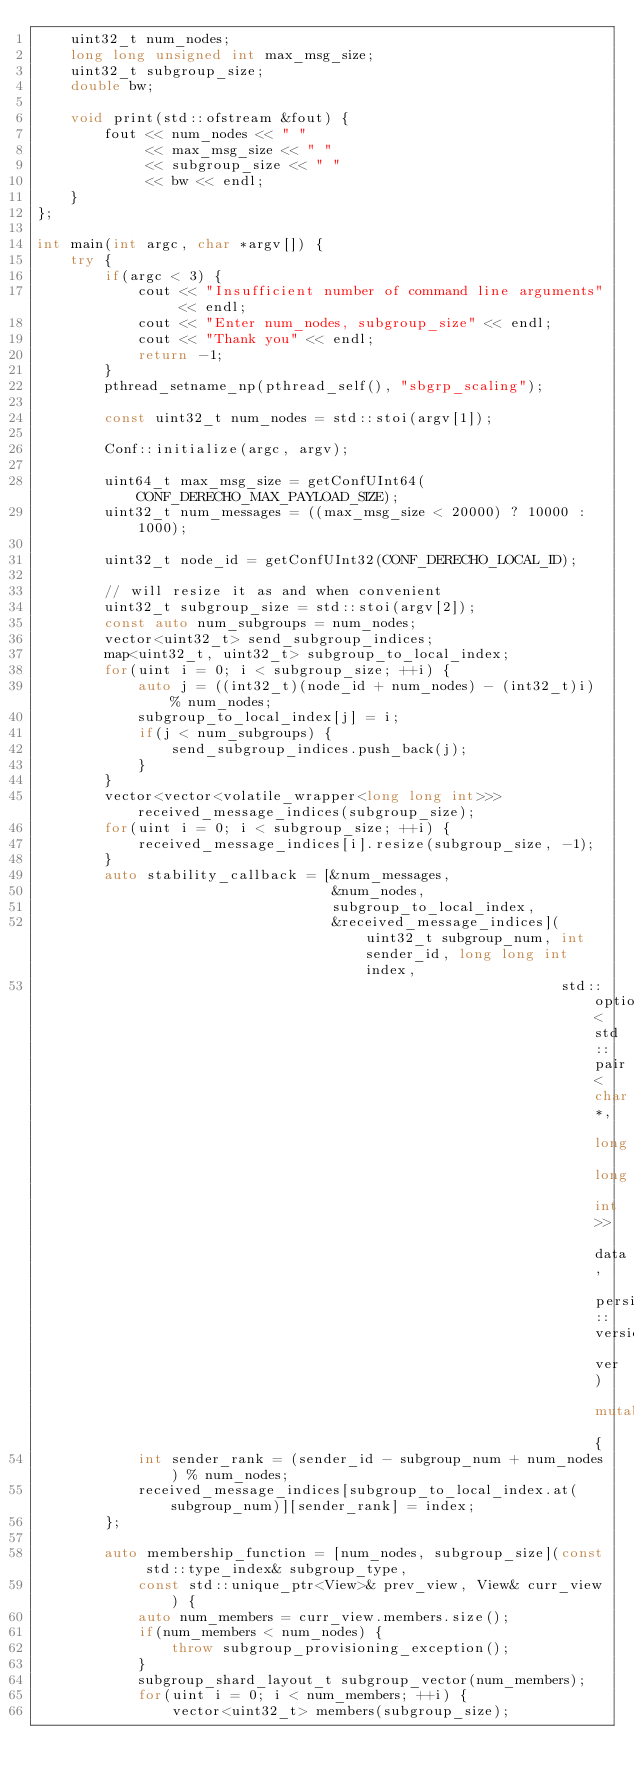<code> <loc_0><loc_0><loc_500><loc_500><_C++_>    uint32_t num_nodes;
    long long unsigned int max_msg_size;
    uint32_t subgroup_size;
    double bw;

    void print(std::ofstream &fout) {
        fout << num_nodes << " "
             << max_msg_size << " "
             << subgroup_size << " "
             << bw << endl;
    }
};

int main(int argc, char *argv[]) {
    try {
        if(argc < 3) {
            cout << "Insufficient number of command line arguments" << endl;
            cout << "Enter num_nodes, subgroup_size" << endl;
            cout << "Thank you" << endl;
            return -1;
        }
        pthread_setname_np(pthread_self(), "sbgrp_scaling");

        const uint32_t num_nodes = std::stoi(argv[1]);

        Conf::initialize(argc, argv);

        uint64_t max_msg_size = getConfUInt64(CONF_DERECHO_MAX_PAYLOAD_SIZE);
        uint32_t num_messages = ((max_msg_size < 20000) ? 10000 : 1000);

        uint32_t node_id = getConfUInt32(CONF_DERECHO_LOCAL_ID);

        // will resize it as and when convenient
        uint32_t subgroup_size = std::stoi(argv[2]);
        const auto num_subgroups = num_nodes;
        vector<uint32_t> send_subgroup_indices;
        map<uint32_t, uint32_t> subgroup_to_local_index;
        for(uint i = 0; i < subgroup_size; ++i) {
            auto j = ((int32_t)(node_id + num_nodes) - (int32_t)i) % num_nodes;
            subgroup_to_local_index[j] = i;
            if(j < num_subgroups) {
                send_subgroup_indices.push_back(j);
            }
        }
        vector<vector<volatile_wrapper<long long int>>> received_message_indices(subgroup_size);
        for(uint i = 0; i < subgroup_size; ++i) {
            received_message_indices[i].resize(subgroup_size, -1);
        }
        auto stability_callback = [&num_messages,
                                   &num_nodes,
                                   subgroup_to_local_index,
                                   &received_message_indices](uint32_t subgroup_num, int sender_id, long long int index,
                                                              std::optional<std::pair<char*, long long int>> data, persistent::version_t ver) mutable {
            int sender_rank = (sender_id - subgroup_num + num_nodes) % num_nodes;
            received_message_indices[subgroup_to_local_index.at(subgroup_num)][sender_rank] = index;
        };

        auto membership_function = [num_nodes, subgroup_size](const std::type_index& subgroup_type,
            const std::unique_ptr<View>& prev_view, View& curr_view) {
            auto num_members = curr_view.members.size();
            if(num_members < num_nodes) {
                throw subgroup_provisioning_exception();
            }
            subgroup_shard_layout_t subgroup_vector(num_members);
            for(uint i = 0; i < num_members; ++i) {
                vector<uint32_t> members(subgroup_size);</code> 